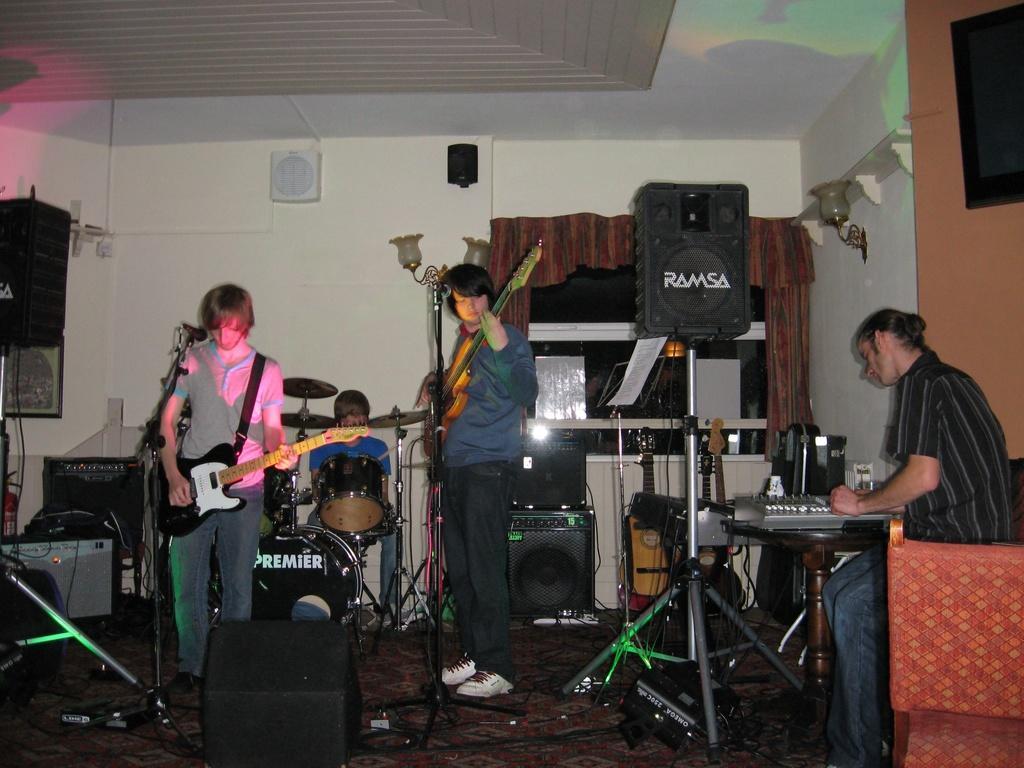Describe this image in one or two sentences. It is a music show there are total four people in the image, the first person to the left is sitting and playing instrument, the second person is playing the guitar, third person is also playing the guitar, in the background the person wearing blue color shirt is playing some drums, in the background there are two big speakers and also small speaker to the Wall, the Wall is off white color. 